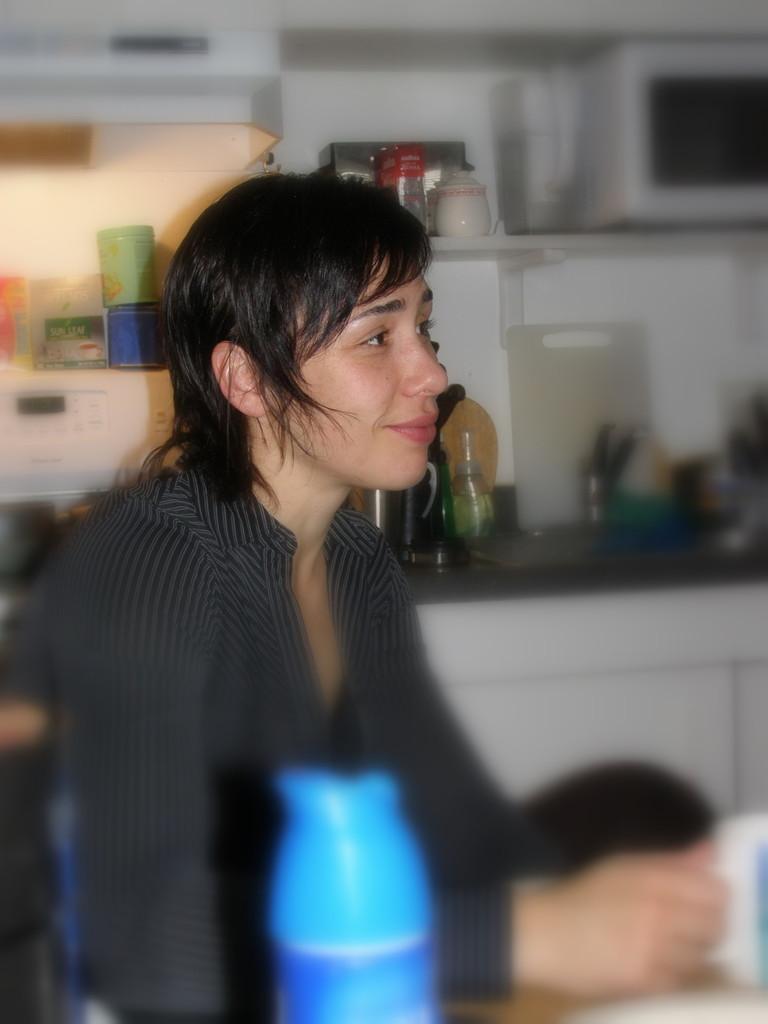Describe this image in one or two sentences. This is a portrait picture. In the center of the picture there is a woman sitting holding a cup. In the background there are bottles, cups and some kitchen utensils. 